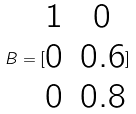Convert formula to latex. <formula><loc_0><loc_0><loc_500><loc_500>B = [ \begin{matrix} 1 & 0 \\ 0 & 0 . 6 \\ 0 & 0 . 8 \end{matrix} ]</formula> 